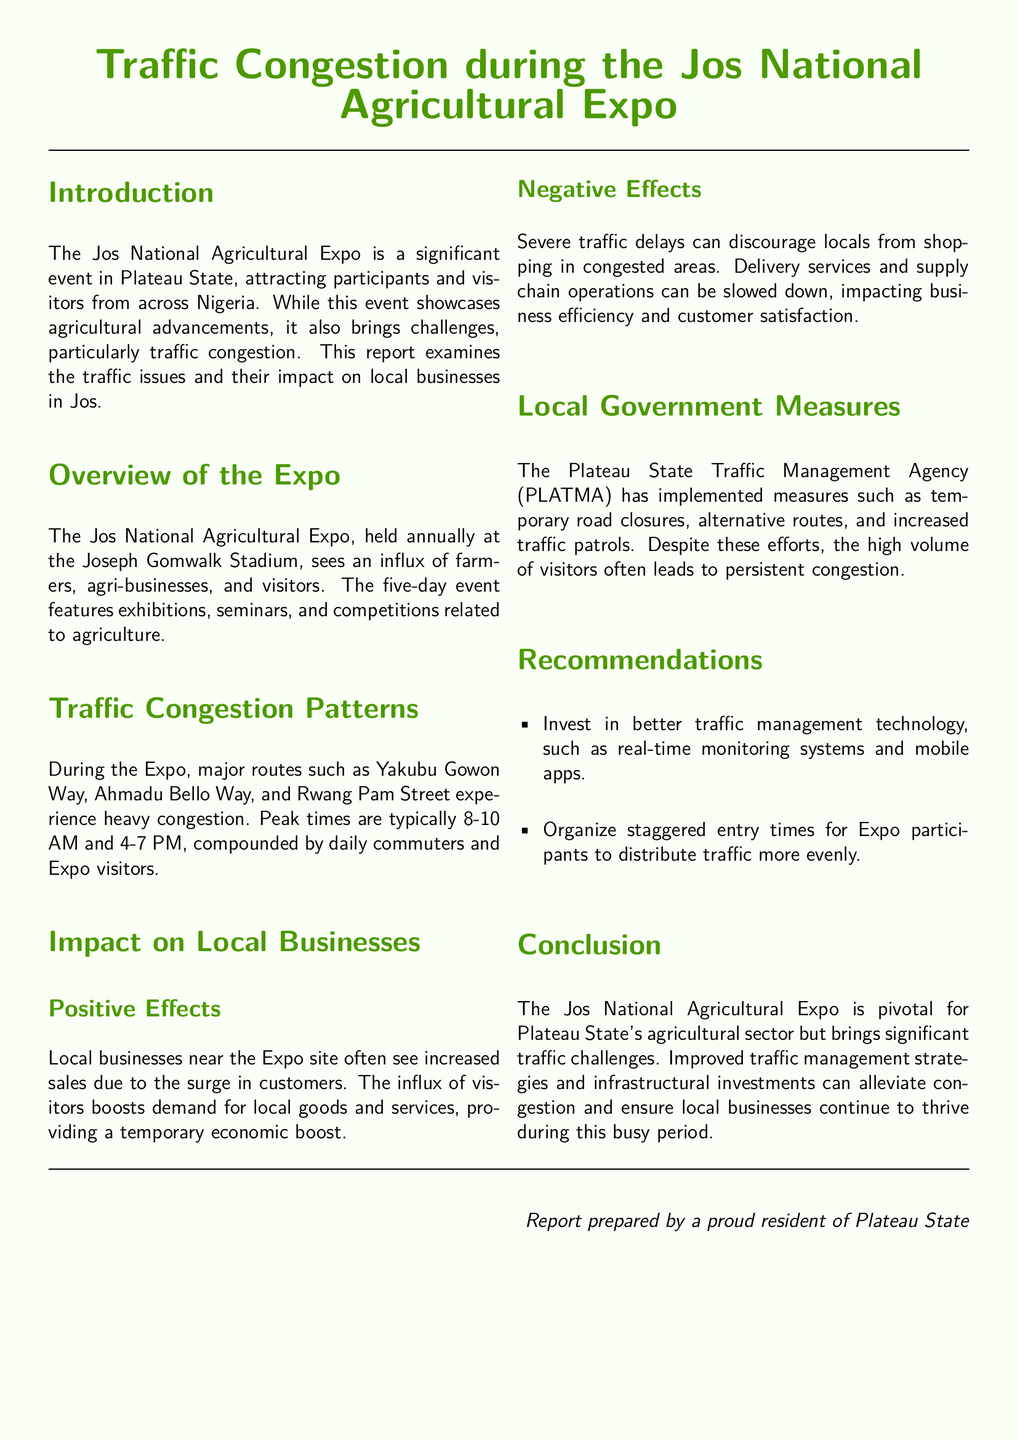What is the location of the Jos National Agricultural Expo? The location of the Expo is the Joseph Gomwalk Stadium.
Answer: Joseph Gomwalk Stadium What are the peak traffic times during the Expo? The peak traffic times are typically 8-10 AM and 4-7 PM.
Answer: 8-10 AM and 4-7 PM Which agency implements traffic management measures during the Expo? The Plateau State Traffic Management Agency (PLATMA) is responsible for implementing these measures.
Answer: PLATMA What is one positive effect of the Expo on local businesses? One positive effect is the increase in sales due to the surge in customers.
Answer: Increase in sales What is a recommendation for improving traffic management during the Expo? A recommendation is to invest in better traffic management technology, such as real-time monitoring systems.
Answer: Better traffic management technology What type of businesses typically benefit from the Expo? Local businesses near the Expo site typically benefit from increased visitors.
Answer: Local businesses What negative effect does traffic congestion have on local shopping? Severe traffic delays can discourage locals from shopping in congested areas.
Answer: Discourage shopping What has been implemented to manage traffic congestion? Temporary road closures and alternative routes have been implemented to manage congestion.
Answer: Temporary road closures, alternative routes 